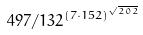<formula> <loc_0><loc_0><loc_500><loc_500>4 9 7 / 1 3 2 ^ { ( 7 \cdot 1 5 2 ) ^ { \sqrt { 2 0 2 } } }</formula> 